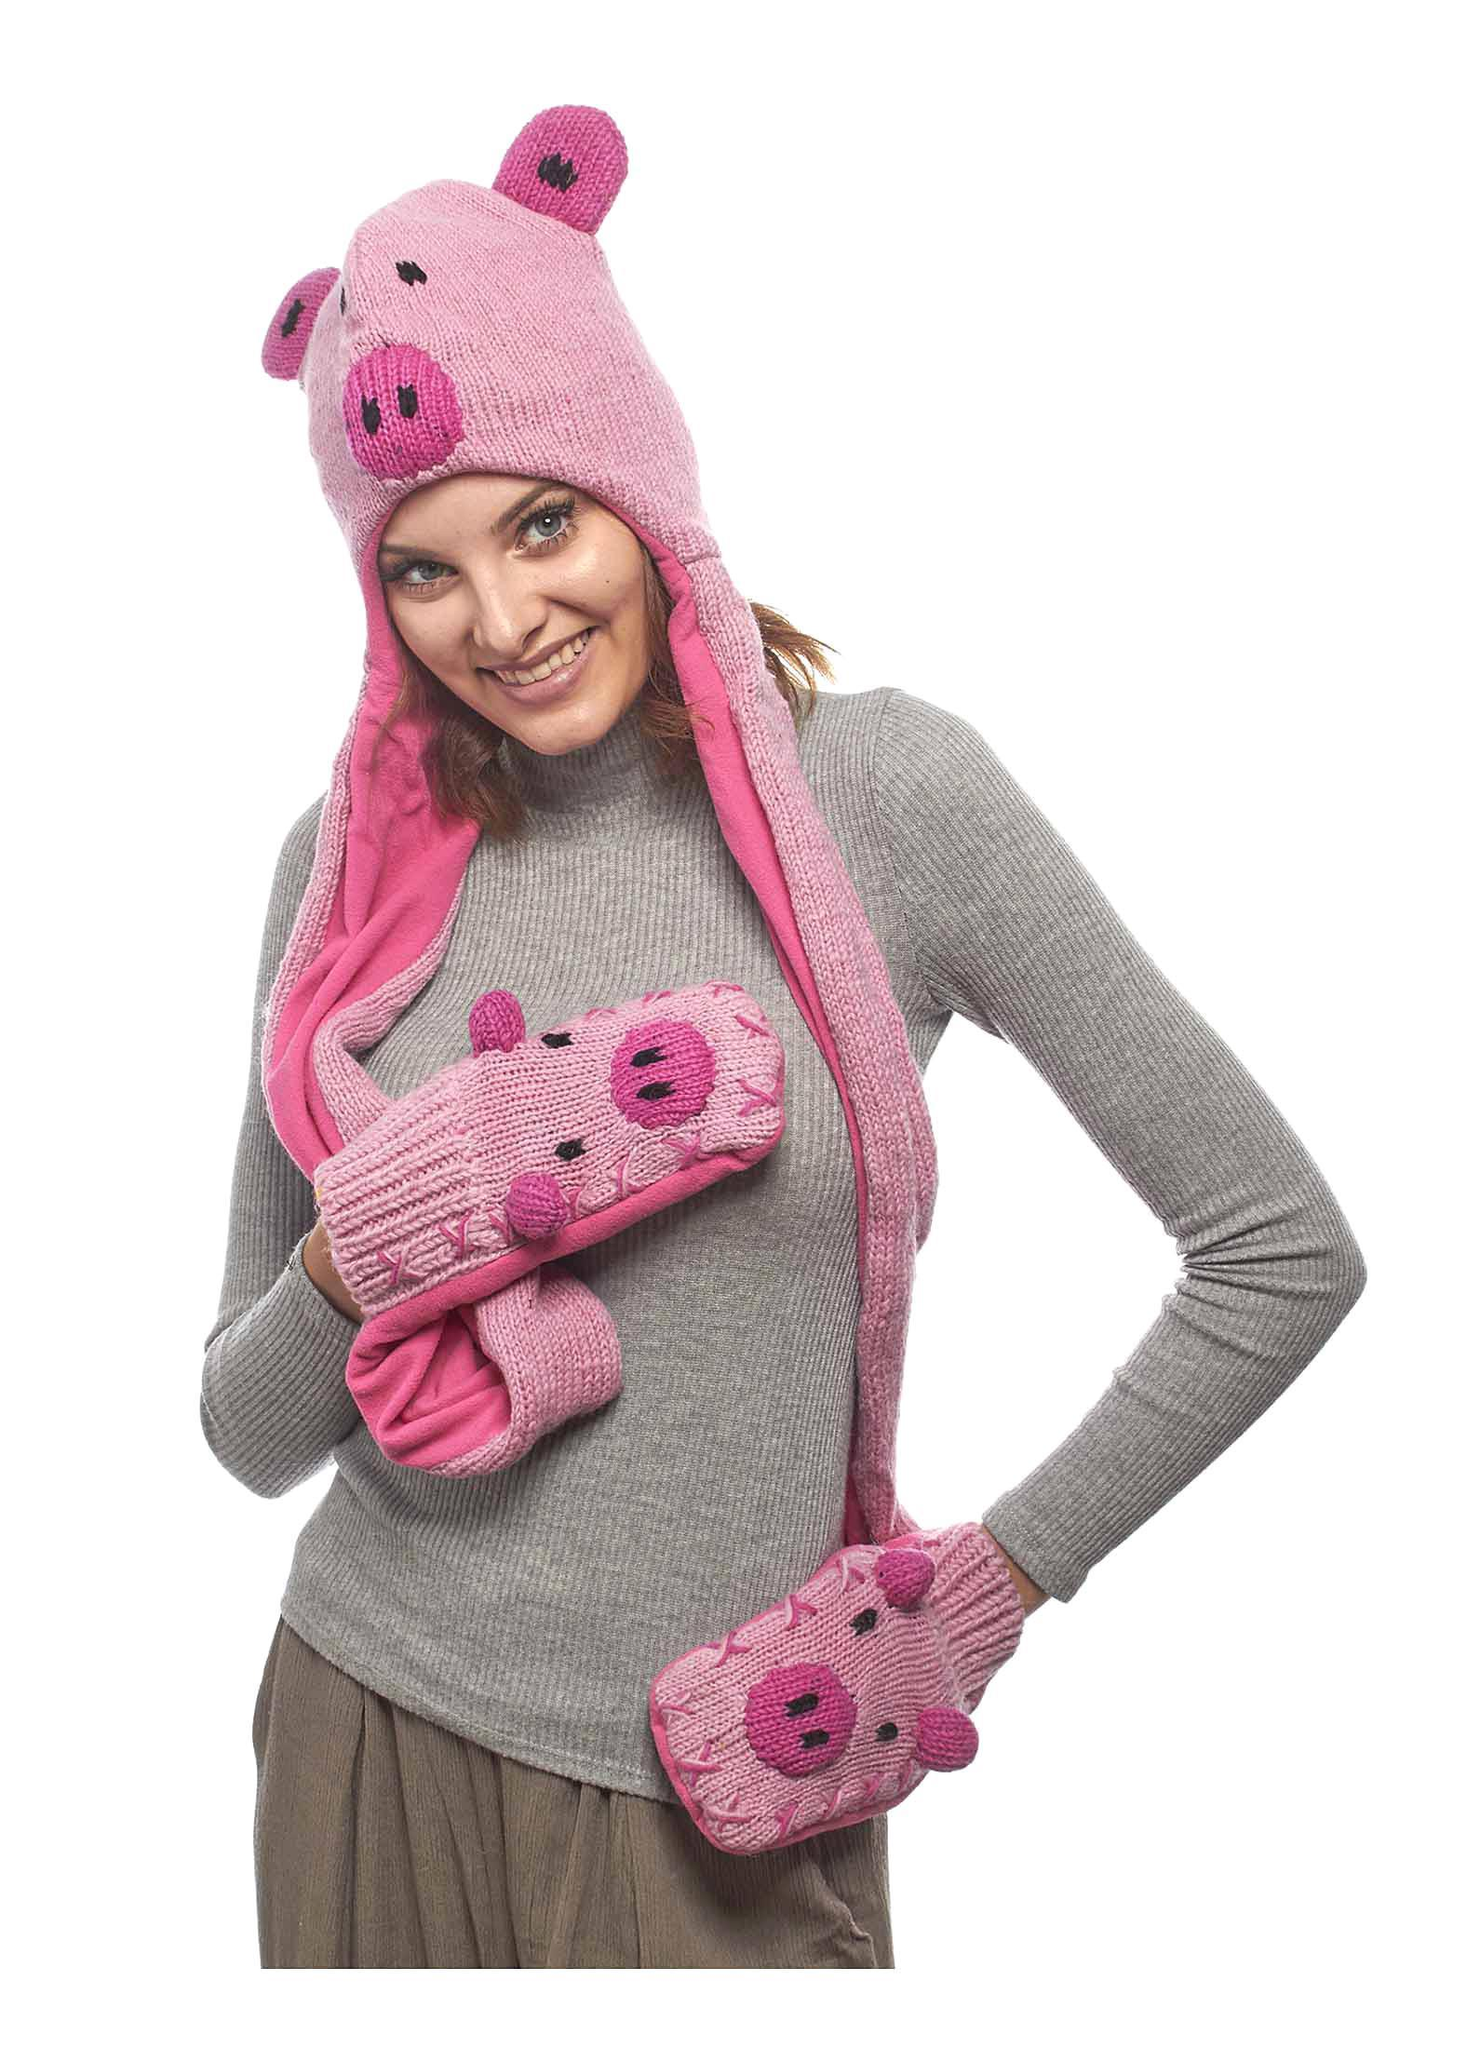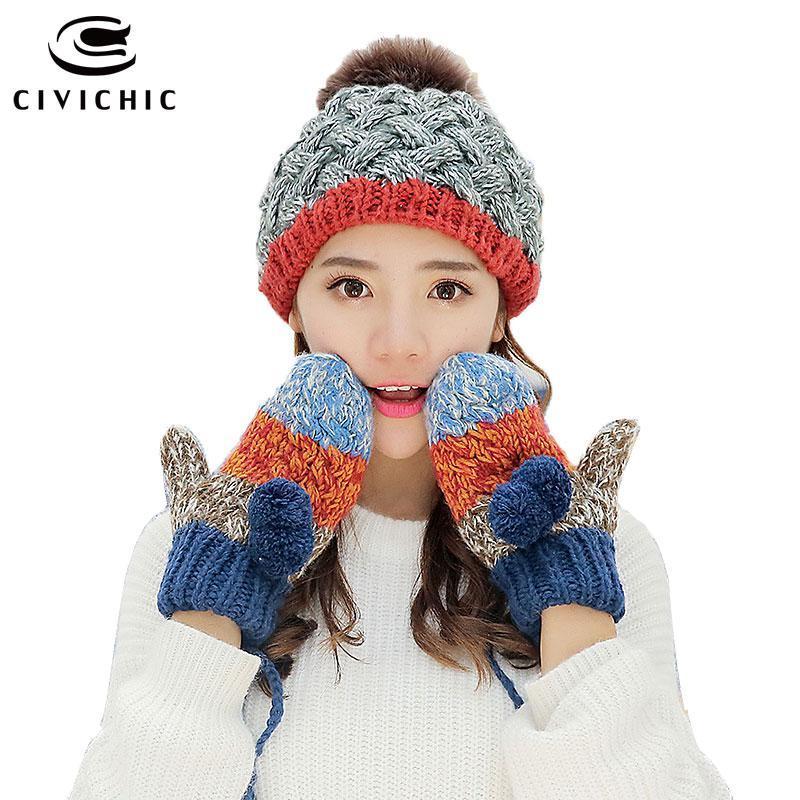The first image is the image on the left, the second image is the image on the right. For the images shown, is this caption "The model in one image wears a hat with animal ears and coordinating mittens." true? Answer yes or no. Yes. 